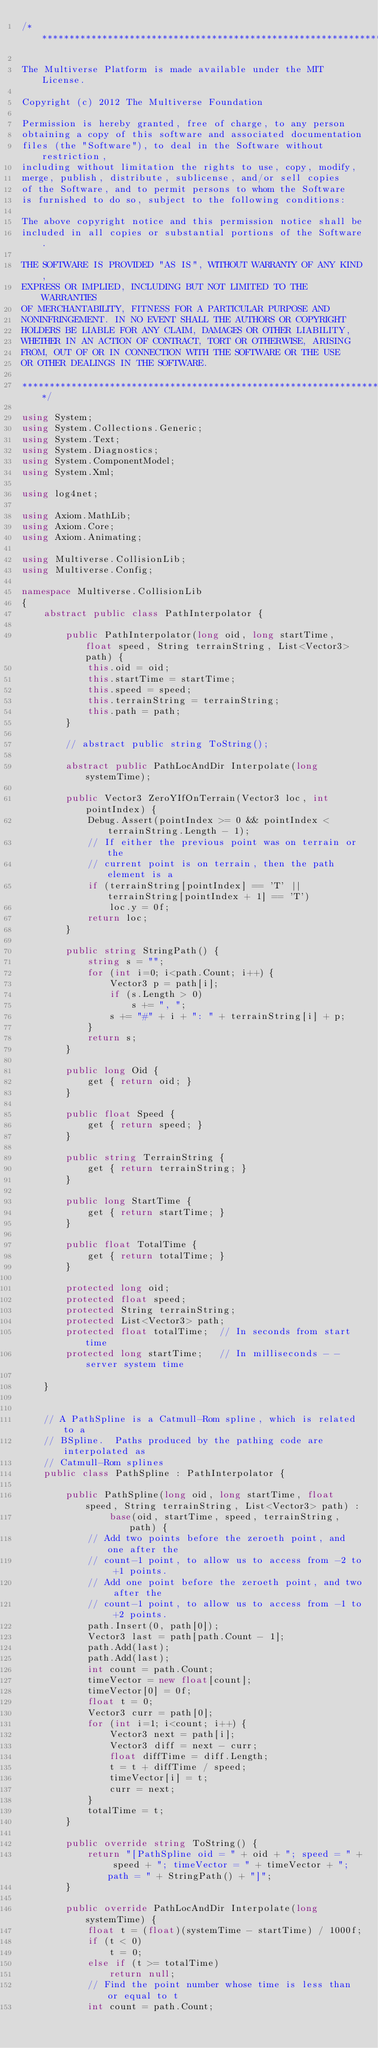Convert code to text. <code><loc_0><loc_0><loc_500><loc_500><_C#_>/********************************************************************

The Multiverse Platform is made available under the MIT License.

Copyright (c) 2012 The Multiverse Foundation

Permission is hereby granted, free of charge, to any person 
obtaining a copy of this software and associated documentation 
files (the "Software"), to deal in the Software without restriction, 
including without limitation the rights to use, copy, modify, 
merge, publish, distribute, sublicense, and/or sell copies 
of the Software, and to permit persons to whom the Software 
is furnished to do so, subject to the following conditions:

The above copyright notice and this permission notice shall be 
included in all copies or substantial portions of the Software.

THE SOFTWARE IS PROVIDED "AS IS", WITHOUT WARRANTY OF ANY KIND, 
EXPRESS OR IMPLIED, INCLUDING BUT NOT LIMITED TO THE WARRANTIES 
OF MERCHANTABILITY, FITNESS FOR A PARTICULAR PURPOSE AND 
NONINFRINGEMENT. IN NO EVENT SHALL THE AUTHORS OR COPYRIGHT 
HOLDERS BE LIABLE FOR ANY CLAIM, DAMAGES OR OTHER LIABILITY, 
WHETHER IN AN ACTION OF CONTRACT, TORT OR OTHERWISE, ARISING 
FROM, OUT OF OR IN CONNECTION WITH THE SOFTWARE OR THE USE 
OR OTHER DEALINGS IN THE SOFTWARE.

*********************************************************************/

using System;
using System.Collections.Generic;
using System.Text;
using System.Diagnostics;
using System.ComponentModel;
using System.Xml;

using log4net;

using Axiom.MathLib;
using Axiom.Core;
using Axiom.Animating;

using Multiverse.CollisionLib;
using Multiverse.Config;

namespace Multiverse.CollisionLib
{
    abstract public class PathInterpolator {
    
        public PathInterpolator(long oid, long startTime, float speed, String terrainString, List<Vector3> path) {
            this.oid = oid;
            this.startTime = startTime;
            this.speed = speed;
            this.terrainString = terrainString;
            this.path = path;
        }

        // abstract public string ToString();

        abstract public PathLocAndDir Interpolate(long systemTime);

        public Vector3 ZeroYIfOnTerrain(Vector3 loc, int pointIndex) {
            Debug.Assert(pointIndex >= 0 && pointIndex < terrainString.Length - 1);
            // If either the previous point was on terrain or the
            // current point is on terrain, then the path element is a 
            if (terrainString[pointIndex] == 'T' || terrainString[pointIndex + 1] == 'T')
                loc.y = 0f;
            return loc;
        }

        public string StringPath() {
            string s = "";
            for (int i=0; i<path.Count; i++) {
                Vector3 p = path[i];
                if (s.Length > 0)
                    s += ", ";
                s += "#" + i + ": " + terrainString[i] + p;
            }
            return s;
        }
        
        public long Oid {
            get { return oid; } 
        }

        public float Speed {
            get { return speed; } 
        }

        public string TerrainString {
            get { return terrainString; } 
        }

        public long StartTime {
            get { return startTime; } 
        }

        public float TotalTime {
            get { return totalTime; } 
        }

        protected long oid;
        protected float speed;
        protected String terrainString;
        protected List<Vector3> path;
        protected float totalTime;  // In seconds from start time
        protected long startTime;   // In milliseconds - - server system time

    }


    // A PathSpline is a Catmull-Rom spline, which is related to a
    // BSpline.  Paths produced by the pathing code are interpolated as
    // Catmull-Rom splines
    public class PathSpline : PathInterpolator {

        public PathSpline(long oid, long startTime, float speed, String terrainString, List<Vector3> path) :
                base(oid, startTime, speed, terrainString, path) {
            // Add two points before the zeroeth point, and one after the
            // count-1 point, to allow us to access from -2 to +1 points.
            // Add one point before the zeroeth point, and two after the
            // count-1 point, to allow us to access from -1 to +2 points.
            path.Insert(0, path[0]);
            Vector3 last = path[path.Count - 1];
            path.Add(last);
            path.Add(last);
            int count = path.Count;
            timeVector = new float[count];
            timeVector[0] = 0f;
            float t = 0;
            Vector3 curr = path[0];
            for (int i=1; i<count; i++) {
                Vector3 next = path[i];
                Vector3 diff = next - curr;
                float diffTime = diff.Length;
                t = t + diffTime / speed;
                timeVector[i] = t;
                curr = next;
            }
            totalTime = t;
        }

        public override string ToString() {
            return "[PathSpline oid = " + oid + "; speed = " + speed + "; timeVector = " + timeVector + "; path = " + StringPath() + "]";
        }

        public override PathLocAndDir Interpolate(long systemTime) {
            float t = (float)(systemTime - startTime) / 1000f;
            if (t < 0)
                t = 0;
            else if (t >= totalTime)
                return null;
            // Find the point number whose time is less than or equal to t
            int count = path.Count;</code> 